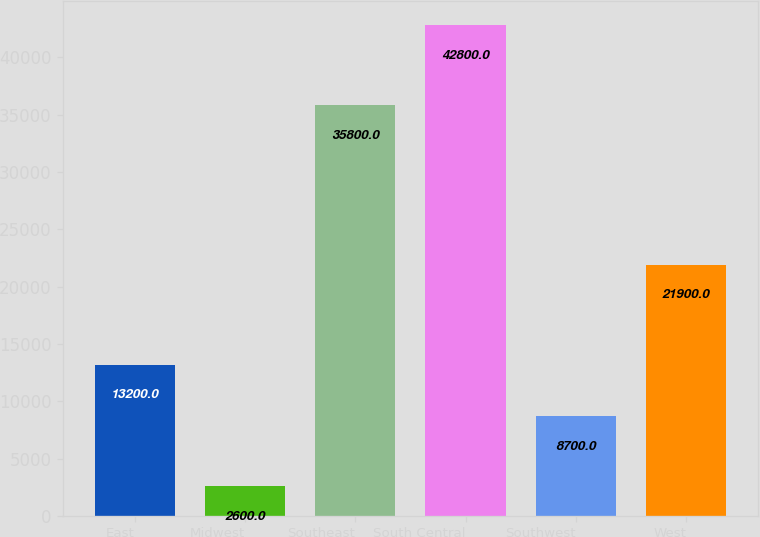Convert chart. <chart><loc_0><loc_0><loc_500><loc_500><bar_chart><fcel>East<fcel>Midwest<fcel>Southeast<fcel>South Central<fcel>Southwest<fcel>West<nl><fcel>13200<fcel>2600<fcel>35800<fcel>42800<fcel>8700<fcel>21900<nl></chart> 